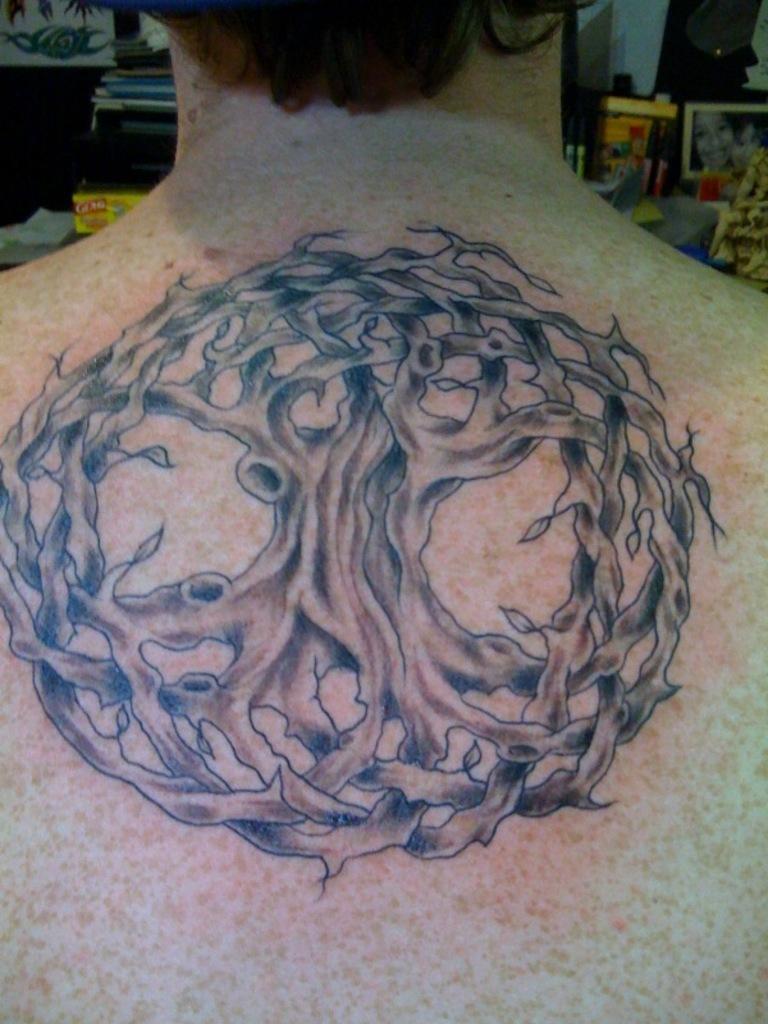In one or two sentences, can you explain what this image depicts? We can see tattoo on a person. Background we can see photo and some objects. 